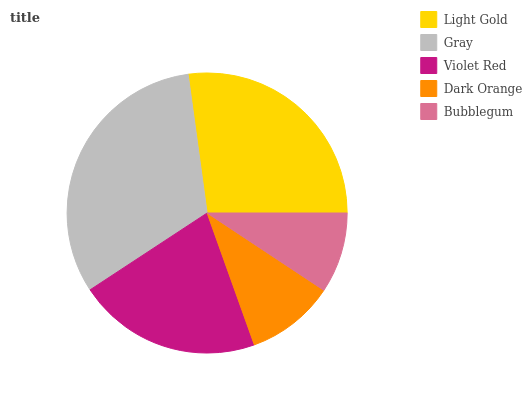Is Bubblegum the minimum?
Answer yes or no. Yes. Is Gray the maximum?
Answer yes or no. Yes. Is Violet Red the minimum?
Answer yes or no. No. Is Violet Red the maximum?
Answer yes or no. No. Is Gray greater than Violet Red?
Answer yes or no. Yes. Is Violet Red less than Gray?
Answer yes or no. Yes. Is Violet Red greater than Gray?
Answer yes or no. No. Is Gray less than Violet Red?
Answer yes or no. No. Is Violet Red the high median?
Answer yes or no. Yes. Is Violet Red the low median?
Answer yes or no. Yes. Is Dark Orange the high median?
Answer yes or no. No. Is Bubblegum the low median?
Answer yes or no. No. 